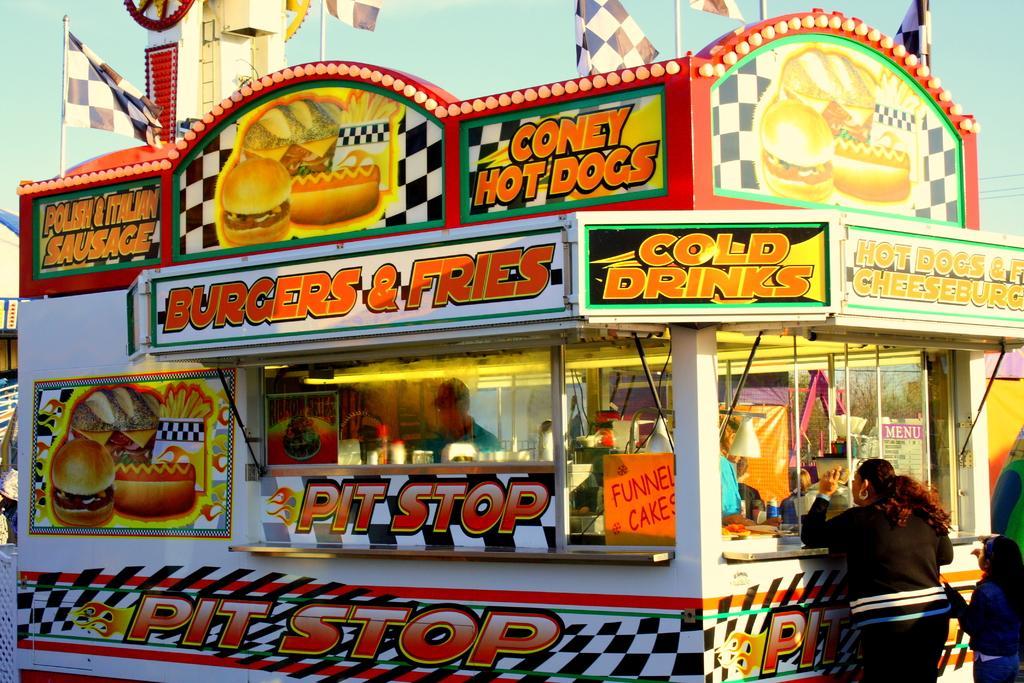Describe this image in one or two sentences. In this image in the foreground there is one truck, and in the truck there are some utensils and on the right side of the image there are some people standing and also there are some boards. On the boards there is text and also we could see some poles, and on the truck there is text and an image of some food items. And in the background there are some poles flags and tower and some objects, at the top of the image there is sky. 